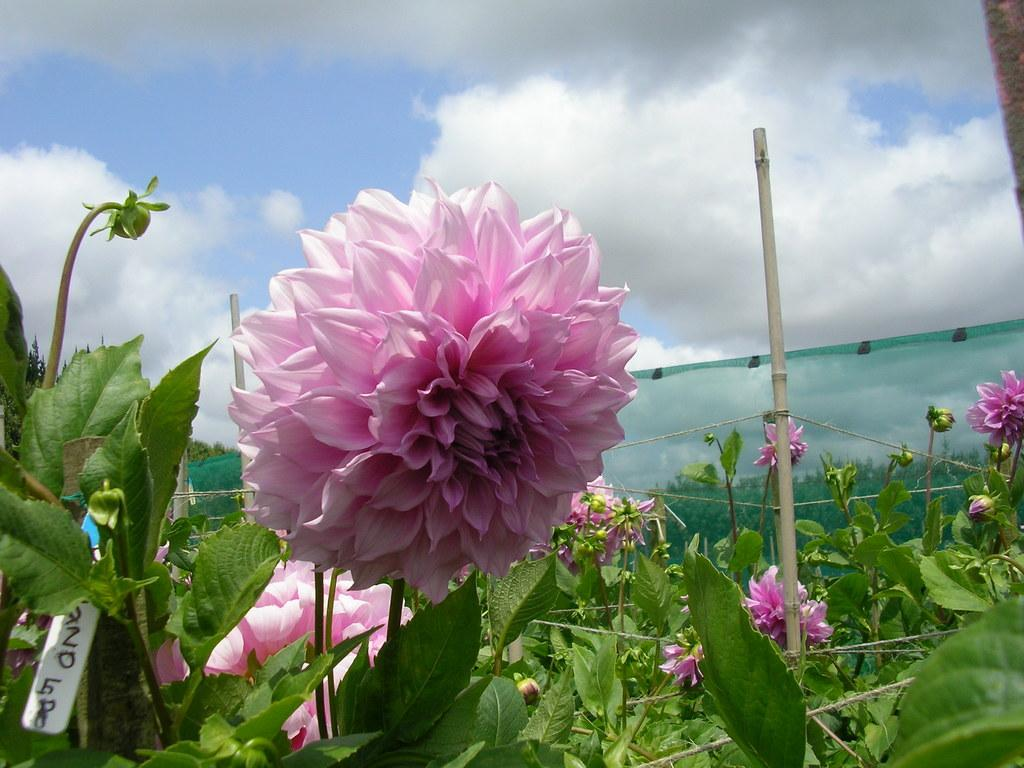What is the main subject of the picture? The main subject of the picture is a flower. Can you describe the flower in the picture? The flower has pink petals. What else can be seen in the picture besides the flower? There are plants in the picture. What is visible in the background of the picture? The sky is clear in the background. What type of coil is wrapped around the stem of the flower in the image? There is no coil present around the stem of the flower in the image. How many stitches are visible on the petals of the flower in the image? The petals of the flower in the image do not have stitches, as they are natural plant parts. 